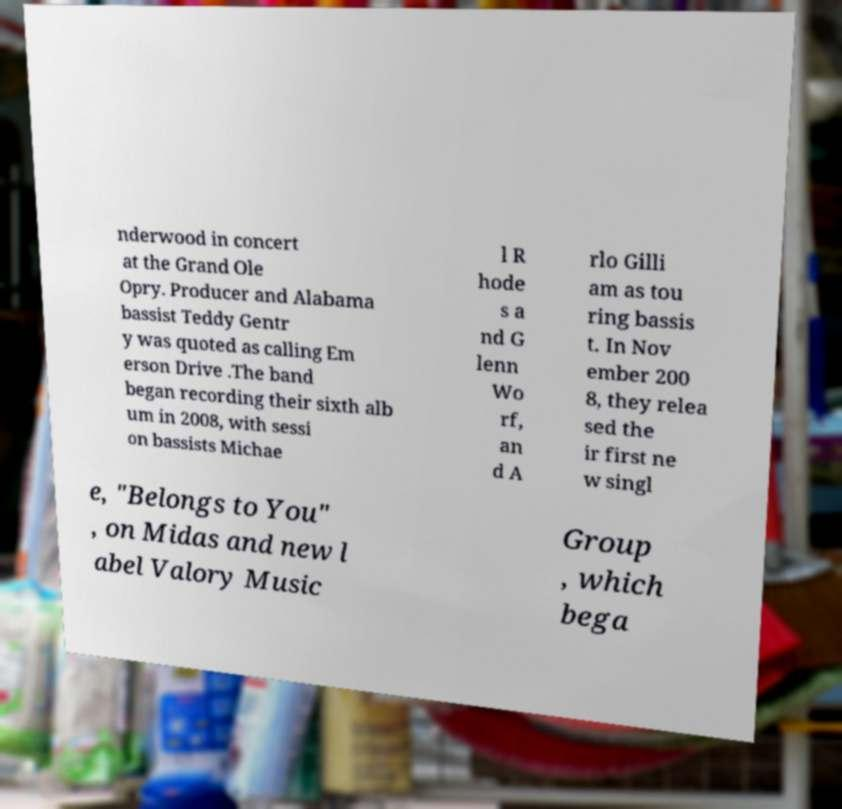Please identify and transcribe the text found in this image. nderwood in concert at the Grand Ole Opry. Producer and Alabama bassist Teddy Gentr y was quoted as calling Em erson Drive .The band began recording their sixth alb um in 2008, with sessi on bassists Michae l R hode s a nd G lenn Wo rf, an d A rlo Gilli am as tou ring bassis t. In Nov ember 200 8, they relea sed the ir first ne w singl e, "Belongs to You" , on Midas and new l abel Valory Music Group , which bega 